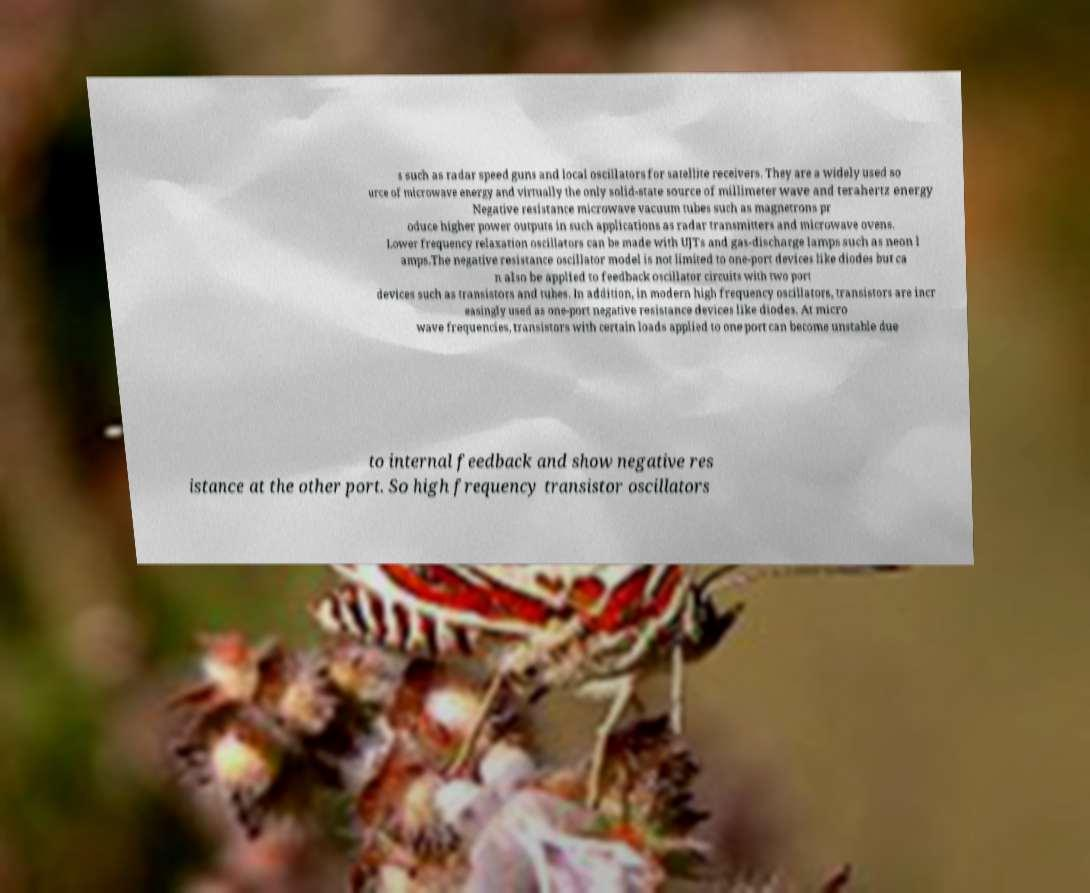For documentation purposes, I need the text within this image transcribed. Could you provide that? s such as radar speed guns and local oscillators for satellite receivers. They are a widely used so urce of microwave energy and virtually the only solid-state source of millimeter wave and terahertz energy Negative resistance microwave vacuum tubes such as magnetrons pr oduce higher power outputs in such applications as radar transmitters and microwave ovens. Lower frequency relaxation oscillators can be made with UJTs and gas-discharge lamps such as neon l amps.The negative resistance oscillator model is not limited to one-port devices like diodes but ca n also be applied to feedback oscillator circuits with two port devices such as transistors and tubes. In addition, in modern high frequency oscillators, transistors are incr easingly used as one-port negative resistance devices like diodes. At micro wave frequencies, transistors with certain loads applied to one port can become unstable due to internal feedback and show negative res istance at the other port. So high frequency transistor oscillators 